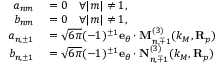<formula> <loc_0><loc_0><loc_500><loc_500>\begin{array} { r l } { a _ { n m } } & = 0 \quad \forall | m | \neq 1 , } \\ { b _ { n m } } & = 0 \quad \forall | m | \neq 1 , } \\ { a _ { n , \pm 1 } } & = \sqrt { 6 \pi } ( - 1 ) ^ { \pm 1 } e _ { \theta } \cdot M _ { n , \mp 1 } ^ { ( 3 ) } ( k _ { M } , R _ { p } ) } \\ { b _ { n , \pm 1 } } & = \sqrt { 6 \pi } ( - 1 ) ^ { \pm 1 } e _ { \theta } \cdot N _ { n , \mp 1 } ^ { ( 3 ) } ( k _ { M } , R _ { p } ) } \end{array}</formula> 